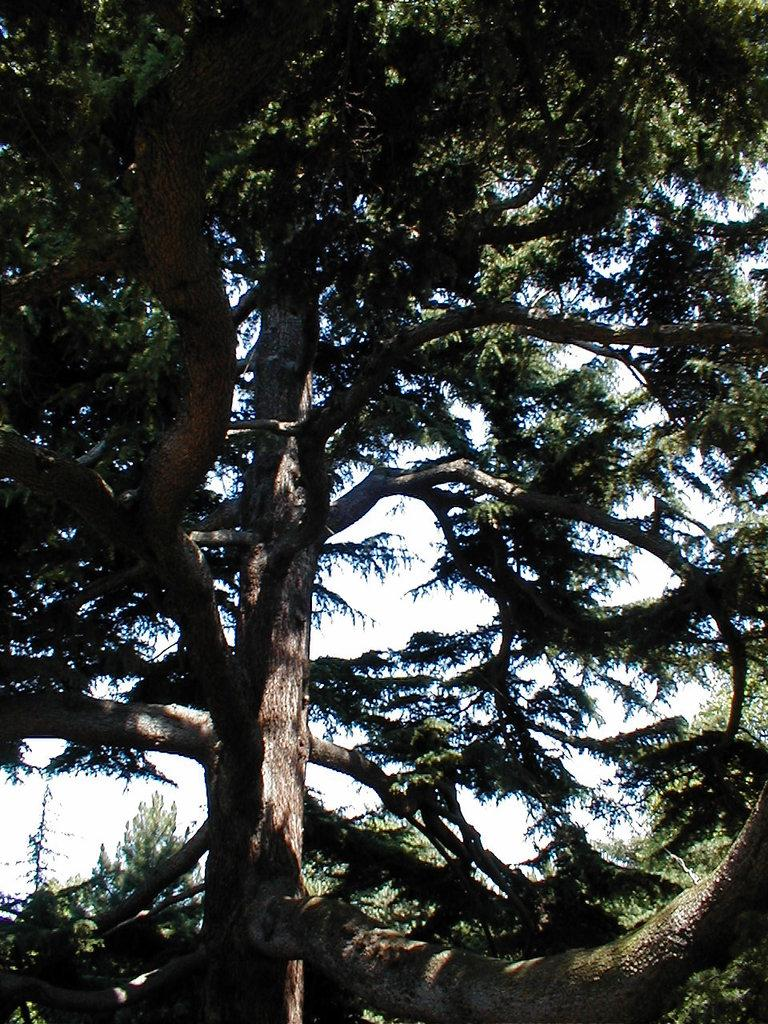What type of vegetation can be seen in the image? There are trees in the image. How are the trees distributed in the image? The trees are around the area of the image. What type of experience can be gained from the tomatoes in the image? There are no tomatoes present in the image, so it is not possible to gain any experience from them. 